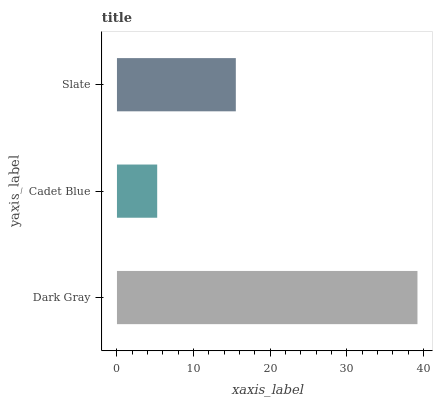Is Cadet Blue the minimum?
Answer yes or no. Yes. Is Dark Gray the maximum?
Answer yes or no. Yes. Is Slate the minimum?
Answer yes or no. No. Is Slate the maximum?
Answer yes or no. No. Is Slate greater than Cadet Blue?
Answer yes or no. Yes. Is Cadet Blue less than Slate?
Answer yes or no. Yes. Is Cadet Blue greater than Slate?
Answer yes or no. No. Is Slate less than Cadet Blue?
Answer yes or no. No. Is Slate the high median?
Answer yes or no. Yes. Is Slate the low median?
Answer yes or no. Yes. Is Cadet Blue the high median?
Answer yes or no. No. Is Dark Gray the low median?
Answer yes or no. No. 